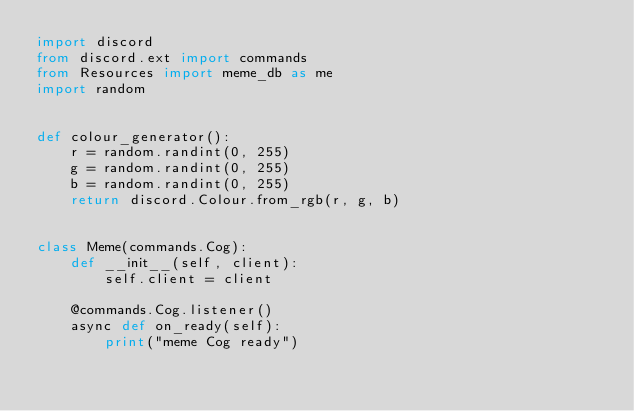<code> <loc_0><loc_0><loc_500><loc_500><_Python_>import discord
from discord.ext import commands
from Resources import meme_db as me
import random


def colour_generator():
    r = random.randint(0, 255)
    g = random.randint(0, 255)
    b = random.randint(0, 255)
    return discord.Colour.from_rgb(r, g, b)


class Meme(commands.Cog):
    def __init__(self, client):
        self.client = client

    @commands.Cog.listener()
    async def on_ready(self):
        print("meme Cog ready")
</code> 